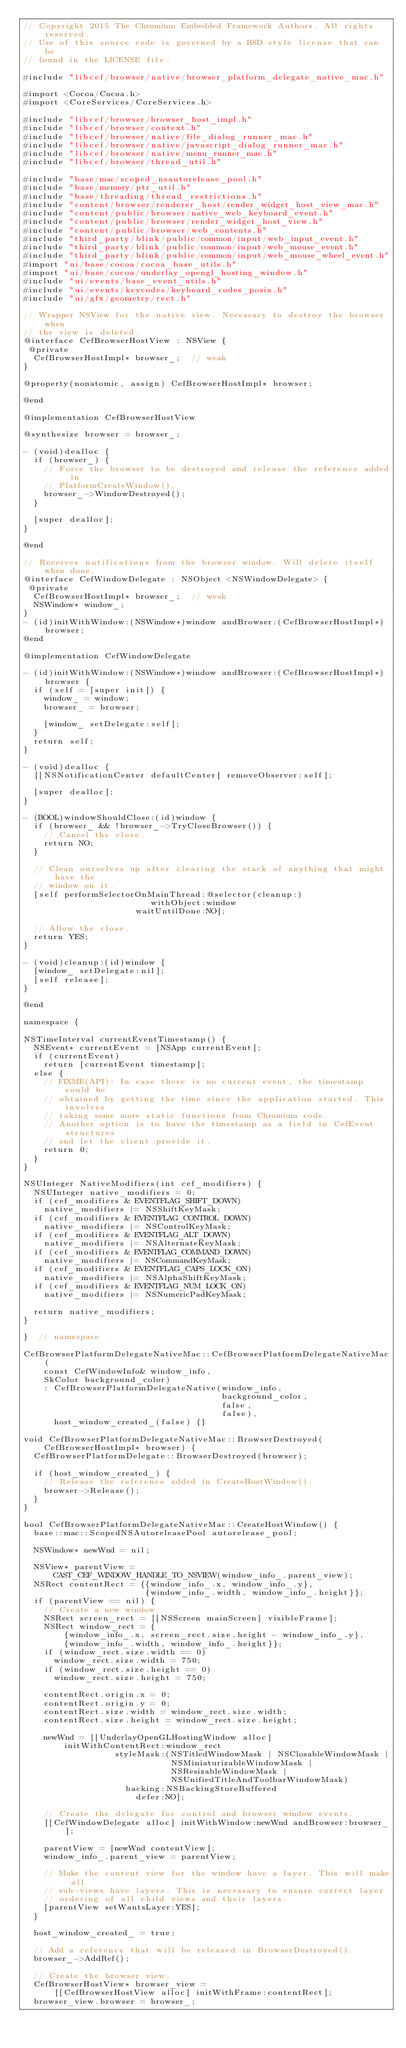<code> <loc_0><loc_0><loc_500><loc_500><_ObjectiveC_>// Copyright 2015 The Chromium Embedded Framework Authors. All rights reserved.
// Use of this source code is governed by a BSD-style license that can be
// found in the LICENSE file.

#include "libcef/browser/native/browser_platform_delegate_native_mac.h"

#import <Cocoa/Cocoa.h>
#import <CoreServices/CoreServices.h>

#include "libcef/browser/browser_host_impl.h"
#include "libcef/browser/context.h"
#include "libcef/browser/native/file_dialog_runner_mac.h"
#include "libcef/browser/native/javascript_dialog_runner_mac.h"
#include "libcef/browser/native/menu_runner_mac.h"
#include "libcef/browser/thread_util.h"

#include "base/mac/scoped_nsautorelease_pool.h"
#include "base/memory/ptr_util.h"
#include "base/threading/thread_restrictions.h"
#include "content/browser/renderer_host/render_widget_host_view_mac.h"
#include "content/public/browser/native_web_keyboard_event.h"
#include "content/public/browser/render_widget_host_view.h"
#include "content/public/browser/web_contents.h"
#include "third_party/blink/public/common/input/web_input_event.h"
#include "third_party/blink/public/common/input/web_mouse_event.h"
#include "third_party/blink/public/common/input/web_mouse_wheel_event.h"
#import "ui/base/cocoa/cocoa_base_utils.h"
#import "ui/base/cocoa/underlay_opengl_hosting_window.h"
#include "ui/events/base_event_utils.h"
#include "ui/events/keycodes/keyboard_codes_posix.h"
#include "ui/gfx/geometry/rect.h"

// Wrapper NSView for the native view. Necessary to destroy the browser when
// the view is deleted.
@interface CefBrowserHostView : NSView {
 @private
  CefBrowserHostImpl* browser_;  // weak
}

@property(nonatomic, assign) CefBrowserHostImpl* browser;

@end

@implementation CefBrowserHostView

@synthesize browser = browser_;

- (void)dealloc {
  if (browser_) {
    // Force the browser to be destroyed and release the reference added in
    // PlatformCreateWindow().
    browser_->WindowDestroyed();
  }

  [super dealloc];
}

@end

// Receives notifications from the browser window. Will delete itself when done.
@interface CefWindowDelegate : NSObject <NSWindowDelegate> {
 @private
  CefBrowserHostImpl* browser_;  // weak
  NSWindow* window_;
}
- (id)initWithWindow:(NSWindow*)window andBrowser:(CefBrowserHostImpl*)browser;
@end

@implementation CefWindowDelegate

- (id)initWithWindow:(NSWindow*)window andBrowser:(CefBrowserHostImpl*)browser {
  if (self = [super init]) {
    window_ = window;
    browser_ = browser;

    [window_ setDelegate:self];
  }
  return self;
}

- (void)dealloc {
  [[NSNotificationCenter defaultCenter] removeObserver:self];

  [super dealloc];
}

- (BOOL)windowShouldClose:(id)window {
  if (browser_ && !browser_->TryCloseBrowser()) {
    // Cancel the close.
    return NO;
  }

  // Clean ourselves up after clearing the stack of anything that might have the
  // window on it.
  [self performSelectorOnMainThread:@selector(cleanup:)
                         withObject:window
                      waitUntilDone:NO];

  // Allow the close.
  return YES;
}

- (void)cleanup:(id)window {
  [window_ setDelegate:nil];
  [self release];
}

@end

namespace {

NSTimeInterval currentEventTimestamp() {
  NSEvent* currentEvent = [NSApp currentEvent];
  if (currentEvent)
    return [currentEvent timestamp];
  else {
    // FIXME(API): In case there is no current event, the timestamp could be
    // obtained by getting the time since the application started. This involves
    // taking some more static functions from Chromium code.
    // Another option is to have the timestamp as a field in CefEvent structures
    // and let the client provide it.
    return 0;
  }
}

NSUInteger NativeModifiers(int cef_modifiers) {
  NSUInteger native_modifiers = 0;
  if (cef_modifiers & EVENTFLAG_SHIFT_DOWN)
    native_modifiers |= NSShiftKeyMask;
  if (cef_modifiers & EVENTFLAG_CONTROL_DOWN)
    native_modifiers |= NSControlKeyMask;
  if (cef_modifiers & EVENTFLAG_ALT_DOWN)
    native_modifiers |= NSAlternateKeyMask;
  if (cef_modifiers & EVENTFLAG_COMMAND_DOWN)
    native_modifiers |= NSCommandKeyMask;
  if (cef_modifiers & EVENTFLAG_CAPS_LOCK_ON)
    native_modifiers |= NSAlphaShiftKeyMask;
  if (cef_modifiers & EVENTFLAG_NUM_LOCK_ON)
    native_modifiers |= NSNumericPadKeyMask;

  return native_modifiers;
}

}  // namespace

CefBrowserPlatformDelegateNativeMac::CefBrowserPlatformDelegateNativeMac(
    const CefWindowInfo& window_info,
    SkColor background_color)
    : CefBrowserPlatformDelegateNative(window_info,
                                       background_color,
                                       false,
                                       false),
      host_window_created_(false) {}

void CefBrowserPlatformDelegateNativeMac::BrowserDestroyed(
    CefBrowserHostImpl* browser) {
  CefBrowserPlatformDelegate::BrowserDestroyed(browser);

  if (host_window_created_) {
    // Release the reference added in CreateHostWindow().
    browser->Release();
  }
}

bool CefBrowserPlatformDelegateNativeMac::CreateHostWindow() {
  base::mac::ScopedNSAutoreleasePool autorelease_pool;

  NSWindow* newWnd = nil;

  NSView* parentView =
      CAST_CEF_WINDOW_HANDLE_TO_NSVIEW(window_info_.parent_view);
  NSRect contentRect = {{window_info_.x, window_info_.y},
                        {window_info_.width, window_info_.height}};
  if (parentView == nil) {
    // Create a new window.
    NSRect screen_rect = [[NSScreen mainScreen] visibleFrame];
    NSRect window_rect = {
        {window_info_.x, screen_rect.size.height - window_info_.y},
        {window_info_.width, window_info_.height}};
    if (window_rect.size.width == 0)
      window_rect.size.width = 750;
    if (window_rect.size.height == 0)
      window_rect.size.height = 750;

    contentRect.origin.x = 0;
    contentRect.origin.y = 0;
    contentRect.size.width = window_rect.size.width;
    contentRect.size.height = window_rect.size.height;

    newWnd = [[UnderlayOpenGLHostingWindow alloc]
        initWithContentRect:window_rect
                  styleMask:(NSTitledWindowMask | NSClosableWindowMask |
                             NSMiniaturizableWindowMask |
                             NSResizableWindowMask |
                             NSUnifiedTitleAndToolbarWindowMask)
                    backing:NSBackingStoreBuffered
                      defer:NO];

    // Create the delegate for control and browser window events.
    [[CefWindowDelegate alloc] initWithWindow:newWnd andBrowser:browser_];

    parentView = [newWnd contentView];
    window_info_.parent_view = parentView;

    // Make the content view for the window have a layer. This will make all
    // sub-views have layers. This is necessary to ensure correct layer
    // ordering of all child views and their layers.
    [parentView setWantsLayer:YES];
  }

  host_window_created_ = true;

  // Add a reference that will be released in BrowserDestroyed().
  browser_->AddRef();

  // Create the browser view.
  CefBrowserHostView* browser_view =
      [[CefBrowserHostView alloc] initWithFrame:contentRect];
  browser_view.browser = browser_;</code> 